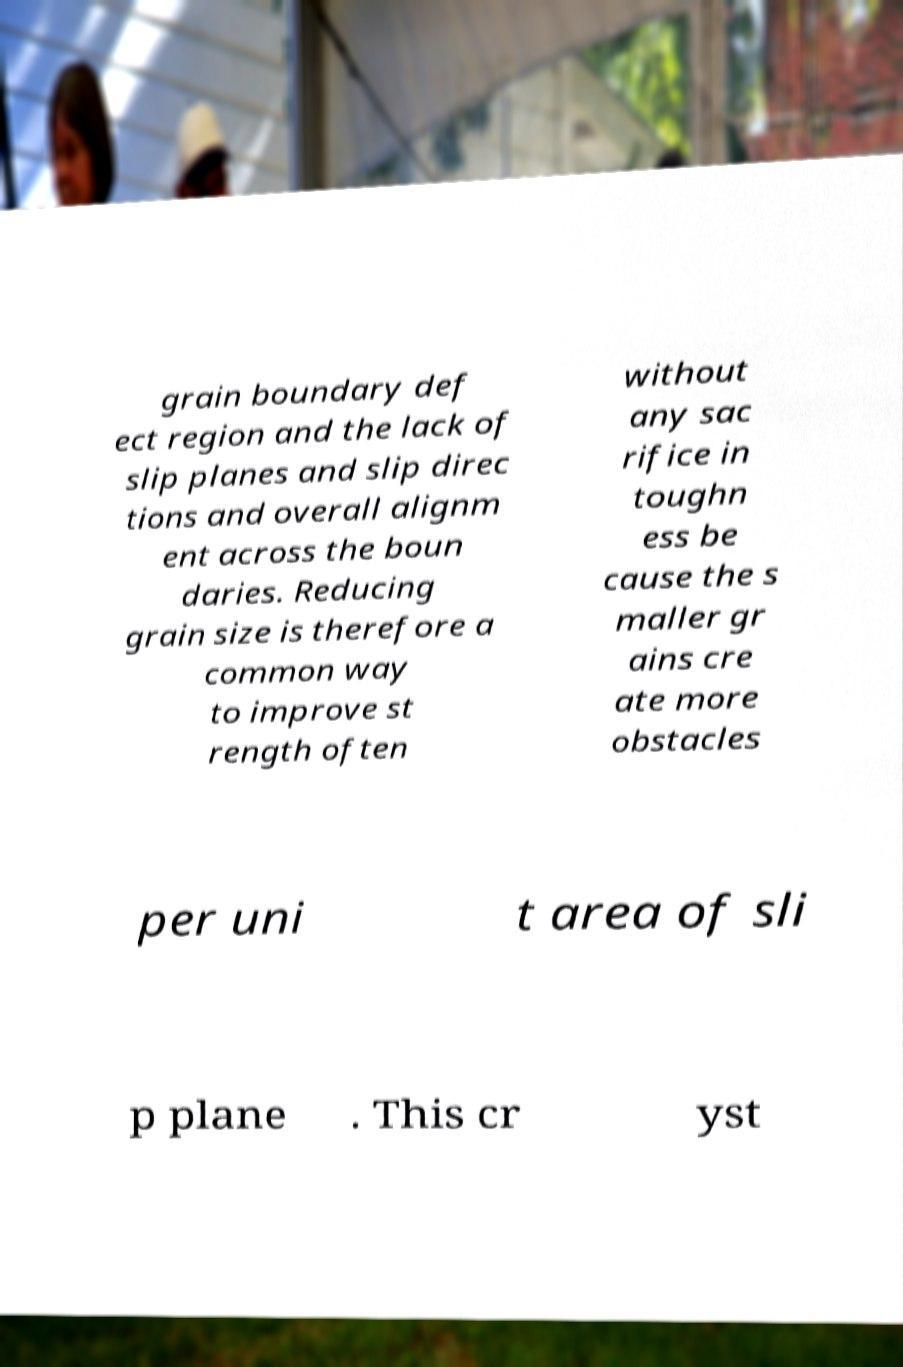Please identify and transcribe the text found in this image. grain boundary def ect region and the lack of slip planes and slip direc tions and overall alignm ent across the boun daries. Reducing grain size is therefore a common way to improve st rength often without any sac rifice in toughn ess be cause the s maller gr ains cre ate more obstacles per uni t area of sli p plane . This cr yst 